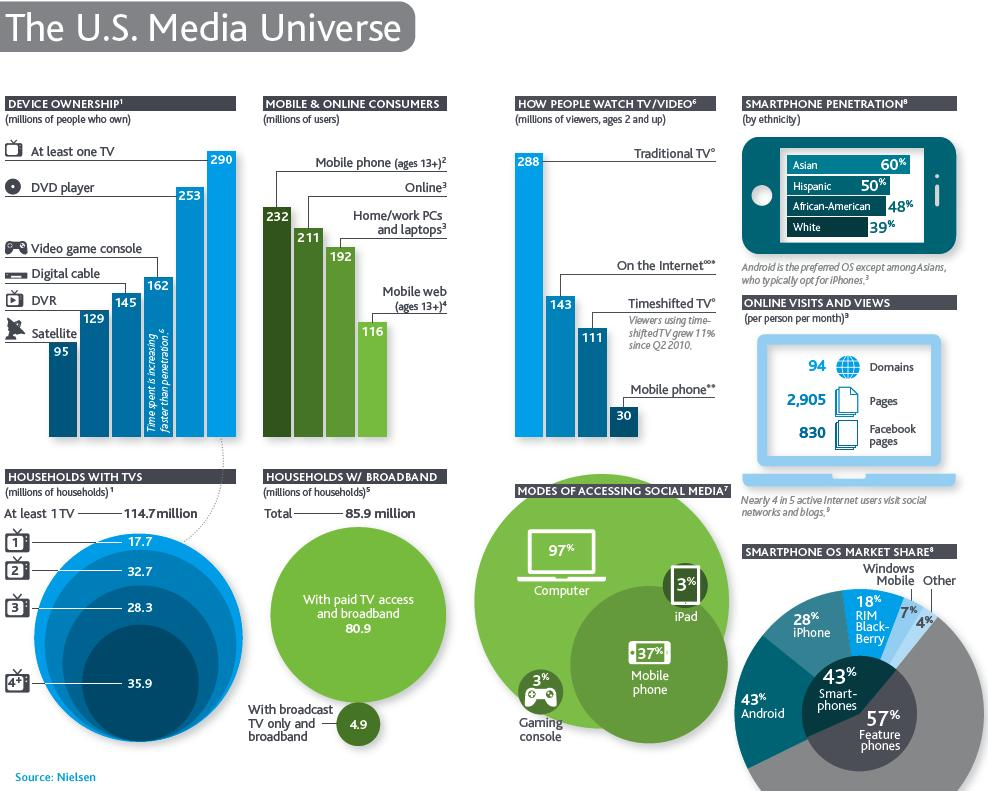List a handful of essential elements in this visual. African American smartphone penetration is higher than any other demographic, including white individuals. Mobile web users are considered to be 13 years old and older. Computers are the most commonly used mode of accessing social media. According to the data, approximately 35.9% of households have more than three TVs. According to the data, approximately 50.4% of households have fewer than three televisions. 